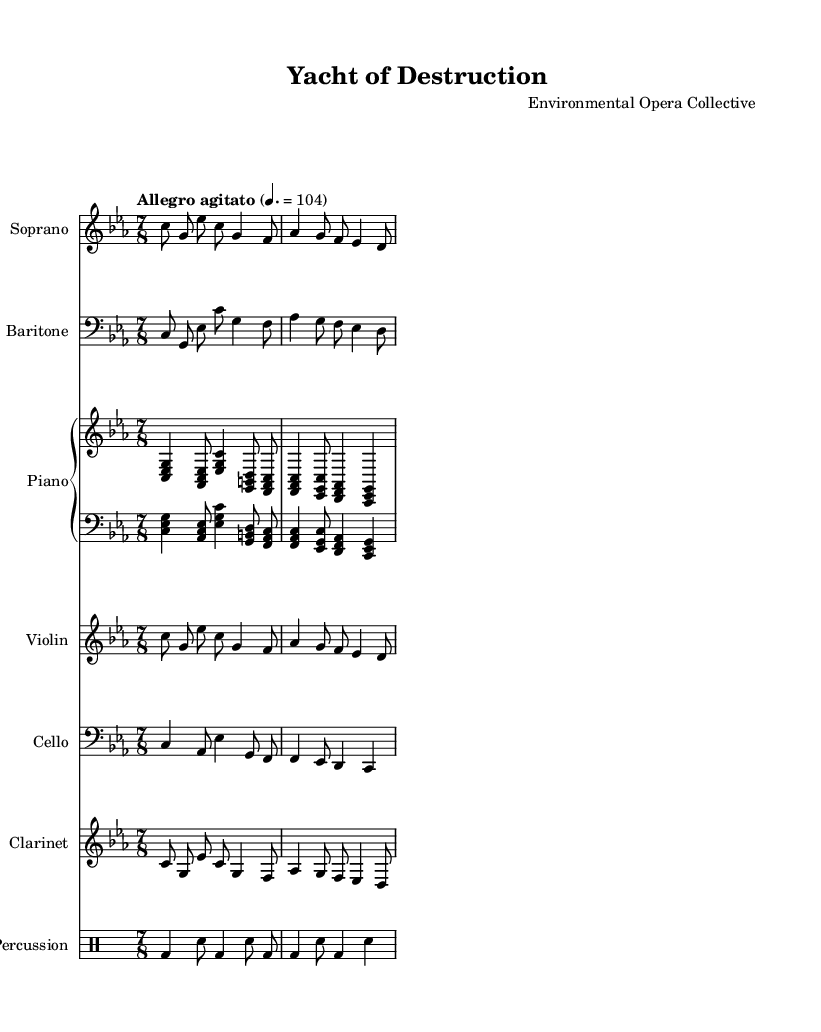what is the title of this opera? The title of the opera is stated in the header as "Yacht of Destruction."
Answer: Yacht of Destruction what is the key signature of this music? The key signature indicated in the global section is C minor, which includes three flats (B, E, and A).
Answer: C minor what is the time signature of this music? The time signature, provided in the global section, shows that the piece is written in 7/8, indicating there are seven beats in each measure, with an eighth note receiving one beat.
Answer: 7/8 what is the tempo marking for this piece? The tempo marking states "Allegro agitato," which indicates a fast and agitated pace. The specific speed is set at 104 beats per minute.
Answer: Allegro agitato how many instruments are prominently featured in this score? By examining the score, we see there are six instruments listed: Soprano, Baritone, Piano (with its two staves), Violin, Cello, Clarinet, and Percussion, making a total of seven parts overall.
Answer: Seven what is the first lyric of the opera? The first lyric in the text section is "Yacht of excess," which is the opening phrase of the opera's vocal lines.
Answer: Yacht of excess what thematic critique does this opera suggest based on its title and lyrics? The title "Yacht of Destruction" and lyrics like "Nature weeps as you caress" suggest a critique of the environmental impacts arising from excessive wealth and luxury lifestyles, particularly related to yachting.
Answer: Excessive wealth's impact on nature 